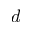<formula> <loc_0><loc_0><loc_500><loc_500>d</formula> 